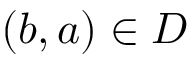Convert formula to latex. <formula><loc_0><loc_0><loc_500><loc_500>( b , a ) \in D</formula> 